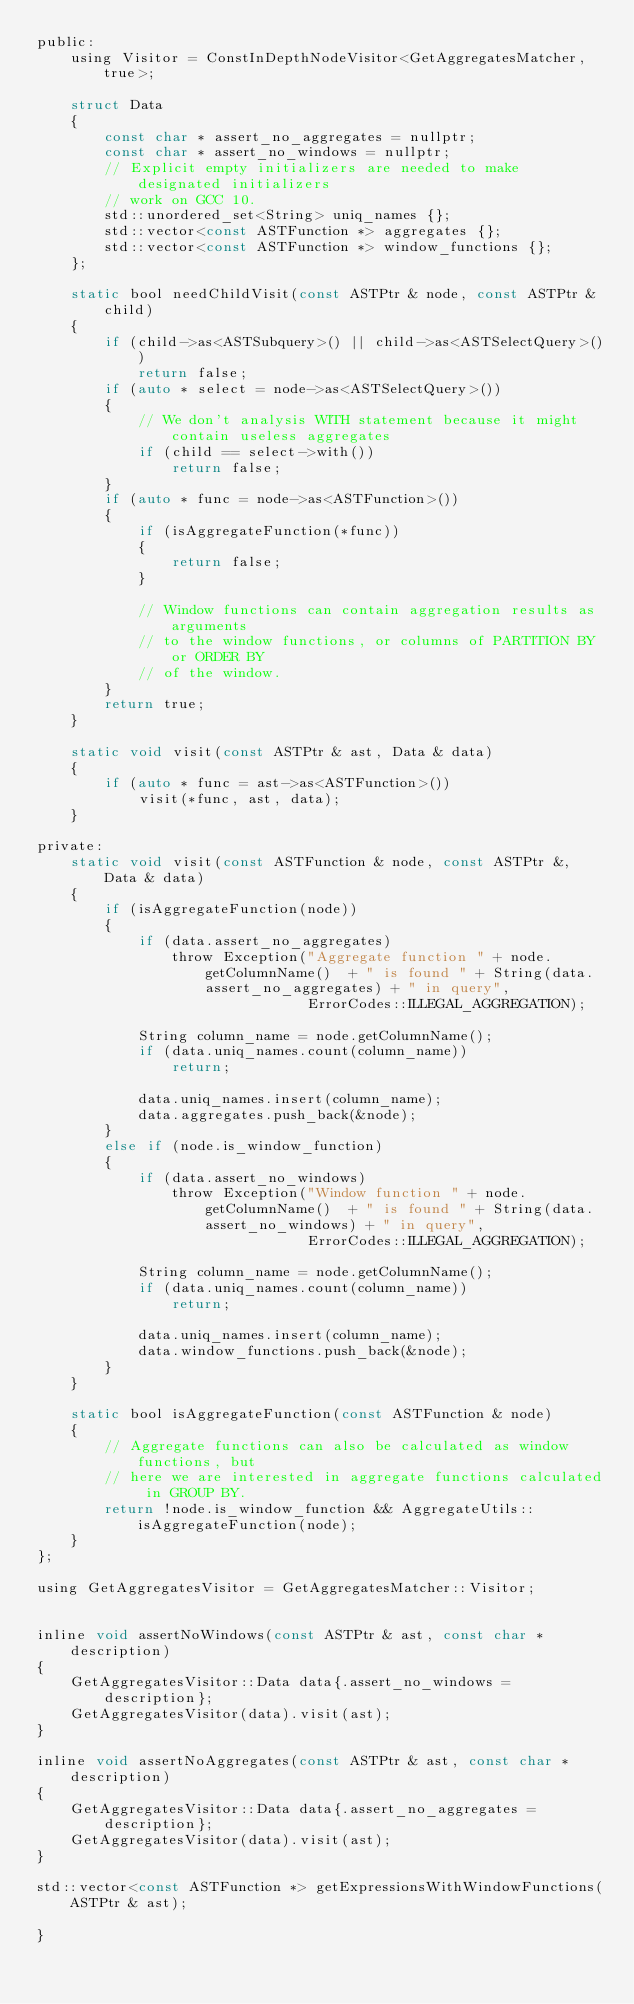Convert code to text. <code><loc_0><loc_0><loc_500><loc_500><_C_>public:
    using Visitor = ConstInDepthNodeVisitor<GetAggregatesMatcher, true>;

    struct Data
    {
        const char * assert_no_aggregates = nullptr;
        const char * assert_no_windows = nullptr;
        // Explicit empty initializers are needed to make designated initializers
        // work on GCC 10.
        std::unordered_set<String> uniq_names {};
        std::vector<const ASTFunction *> aggregates {};
        std::vector<const ASTFunction *> window_functions {};
    };

    static bool needChildVisit(const ASTPtr & node, const ASTPtr & child)
    {
        if (child->as<ASTSubquery>() || child->as<ASTSelectQuery>())
            return false;
        if (auto * select = node->as<ASTSelectQuery>())
        {
            // We don't analysis WITH statement because it might contain useless aggregates
            if (child == select->with())
                return false;
        }
        if (auto * func = node->as<ASTFunction>())
        {
            if (isAggregateFunction(*func))
            {
                return false;
            }

            // Window functions can contain aggregation results as arguments
            // to the window functions, or columns of PARTITION BY or ORDER BY
            // of the window.
        }
        return true;
    }

    static void visit(const ASTPtr & ast, Data & data)
    {
        if (auto * func = ast->as<ASTFunction>())
            visit(*func, ast, data);
    }

private:
    static void visit(const ASTFunction & node, const ASTPtr &, Data & data)
    {
        if (isAggregateFunction(node))
        {
            if (data.assert_no_aggregates)
                throw Exception("Aggregate function " + node.getColumnName()  + " is found " + String(data.assert_no_aggregates) + " in query",
                                ErrorCodes::ILLEGAL_AGGREGATION);

            String column_name = node.getColumnName();
            if (data.uniq_names.count(column_name))
                return;

            data.uniq_names.insert(column_name);
            data.aggregates.push_back(&node);
        }
        else if (node.is_window_function)
        {
            if (data.assert_no_windows)
                throw Exception("Window function " + node.getColumnName()  + " is found " + String(data.assert_no_windows) + " in query",
                                ErrorCodes::ILLEGAL_AGGREGATION);

            String column_name = node.getColumnName();
            if (data.uniq_names.count(column_name))
                return;

            data.uniq_names.insert(column_name);
            data.window_functions.push_back(&node);
        }
    }

    static bool isAggregateFunction(const ASTFunction & node)
    {
        // Aggregate functions can also be calculated as window functions, but
        // here we are interested in aggregate functions calculated in GROUP BY.
        return !node.is_window_function && AggregateUtils::isAggregateFunction(node);
    }
};

using GetAggregatesVisitor = GetAggregatesMatcher::Visitor;


inline void assertNoWindows(const ASTPtr & ast, const char * description)
{
    GetAggregatesVisitor::Data data{.assert_no_windows = description};
    GetAggregatesVisitor(data).visit(ast);
}

inline void assertNoAggregates(const ASTPtr & ast, const char * description)
{
    GetAggregatesVisitor::Data data{.assert_no_aggregates = description};
    GetAggregatesVisitor(data).visit(ast);
}

std::vector<const ASTFunction *> getExpressionsWithWindowFunctions(ASTPtr & ast);

}
</code> 